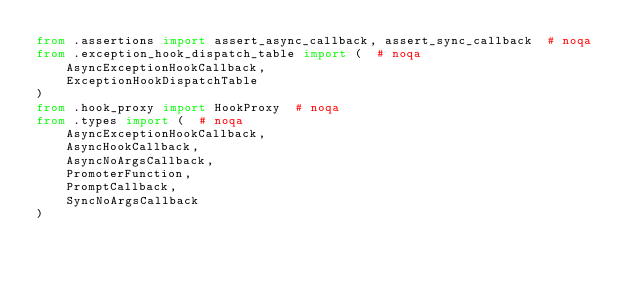Convert code to text. <code><loc_0><loc_0><loc_500><loc_500><_Python_>from .assertions import assert_async_callback, assert_sync_callback  # noqa
from .exception_hook_dispatch_table import (  # noqa
    AsyncExceptionHookCallback,
    ExceptionHookDispatchTable
)
from .hook_proxy import HookProxy  # noqa
from .types import (  # noqa
    AsyncExceptionHookCallback,
    AsyncHookCallback,
    AsyncNoArgsCallback,
    PromoterFunction,
    PromptCallback,
    SyncNoArgsCallback
)
</code> 